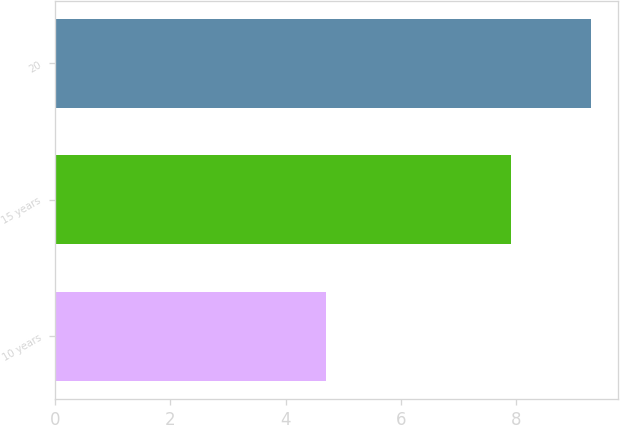Convert chart to OTSL. <chart><loc_0><loc_0><loc_500><loc_500><bar_chart><fcel>10 years<fcel>15 years<fcel>20<nl><fcel>4.7<fcel>7.9<fcel>9.3<nl></chart> 